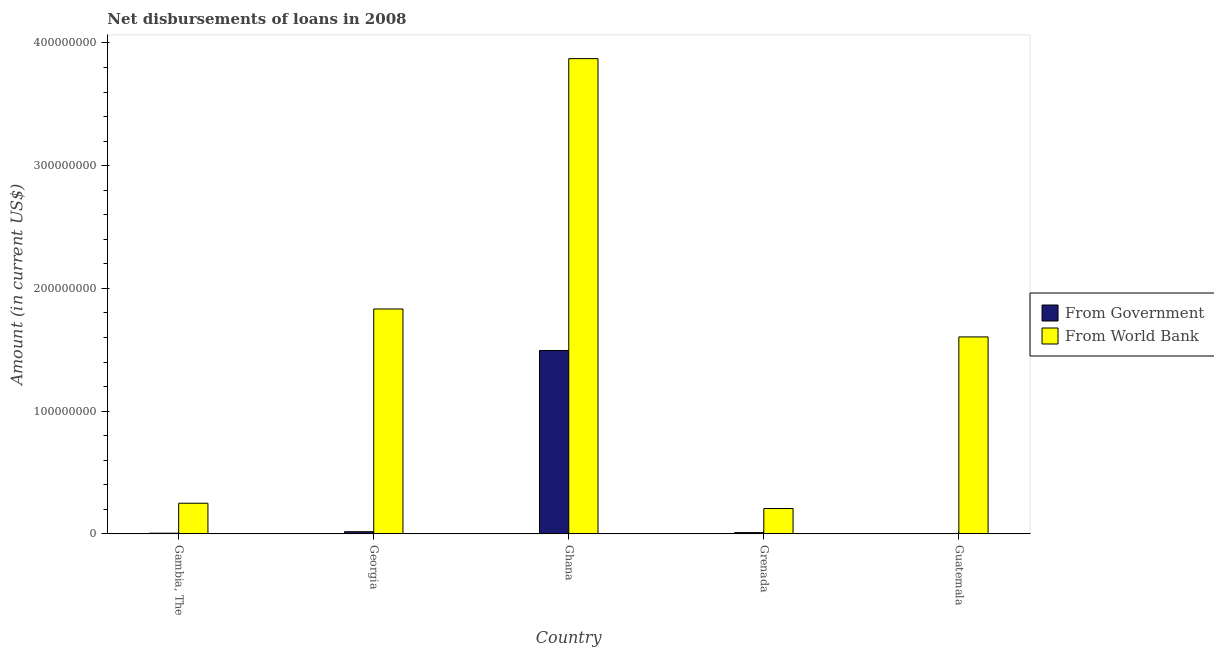How many bars are there on the 5th tick from the right?
Your answer should be compact. 2. What is the label of the 2nd group of bars from the left?
Ensure brevity in your answer.  Georgia. In how many cases, is the number of bars for a given country not equal to the number of legend labels?
Keep it short and to the point. 1. What is the net disbursements of loan from government in Guatemala?
Ensure brevity in your answer.  0. Across all countries, what is the maximum net disbursements of loan from government?
Offer a very short reply. 1.49e+08. Across all countries, what is the minimum net disbursements of loan from world bank?
Keep it short and to the point. 2.07e+07. What is the total net disbursements of loan from government in the graph?
Provide a succinct answer. 1.53e+08. What is the difference between the net disbursements of loan from government in Georgia and that in Ghana?
Your answer should be very brief. -1.48e+08. What is the difference between the net disbursements of loan from government in Grenada and the net disbursements of loan from world bank in Georgia?
Your answer should be very brief. -1.82e+08. What is the average net disbursements of loan from world bank per country?
Your answer should be very brief. 1.55e+08. What is the difference between the net disbursements of loan from world bank and net disbursements of loan from government in Grenada?
Offer a terse response. 1.96e+07. What is the ratio of the net disbursements of loan from world bank in Georgia to that in Guatemala?
Keep it short and to the point. 1.14. Is the difference between the net disbursements of loan from world bank in Gambia, The and Grenada greater than the difference between the net disbursements of loan from government in Gambia, The and Grenada?
Your answer should be compact. Yes. What is the difference between the highest and the second highest net disbursements of loan from government?
Offer a terse response. 1.48e+08. What is the difference between the highest and the lowest net disbursements of loan from government?
Make the answer very short. 1.49e+08. In how many countries, is the net disbursements of loan from government greater than the average net disbursements of loan from government taken over all countries?
Give a very brief answer. 1. Is the sum of the net disbursements of loan from world bank in Gambia, The and Guatemala greater than the maximum net disbursements of loan from government across all countries?
Give a very brief answer. Yes. How many bars are there?
Offer a terse response. 9. How many countries are there in the graph?
Make the answer very short. 5. What is the difference between two consecutive major ticks on the Y-axis?
Your answer should be compact. 1.00e+08. Does the graph contain grids?
Give a very brief answer. No. How many legend labels are there?
Your answer should be very brief. 2. How are the legend labels stacked?
Make the answer very short. Vertical. What is the title of the graph?
Offer a very short reply. Net disbursements of loans in 2008. Does "IMF concessional" appear as one of the legend labels in the graph?
Offer a very short reply. No. What is the label or title of the Y-axis?
Provide a short and direct response. Amount (in current US$). What is the Amount (in current US$) of From Government in Gambia, The?
Your response must be concise. 5.37e+05. What is the Amount (in current US$) in From World Bank in Gambia, The?
Ensure brevity in your answer.  2.50e+07. What is the Amount (in current US$) of From Government in Georgia?
Make the answer very short. 1.75e+06. What is the Amount (in current US$) of From World Bank in Georgia?
Ensure brevity in your answer.  1.83e+08. What is the Amount (in current US$) in From Government in Ghana?
Give a very brief answer. 1.49e+08. What is the Amount (in current US$) in From World Bank in Ghana?
Offer a very short reply. 3.87e+08. What is the Amount (in current US$) in From Government in Grenada?
Your response must be concise. 1.02e+06. What is the Amount (in current US$) in From World Bank in Grenada?
Make the answer very short. 2.07e+07. What is the Amount (in current US$) in From World Bank in Guatemala?
Provide a succinct answer. 1.60e+08. Across all countries, what is the maximum Amount (in current US$) of From Government?
Keep it short and to the point. 1.49e+08. Across all countries, what is the maximum Amount (in current US$) in From World Bank?
Give a very brief answer. 3.87e+08. Across all countries, what is the minimum Amount (in current US$) in From World Bank?
Offer a very short reply. 2.07e+07. What is the total Amount (in current US$) of From Government in the graph?
Provide a short and direct response. 1.53e+08. What is the total Amount (in current US$) of From World Bank in the graph?
Offer a terse response. 7.77e+08. What is the difference between the Amount (in current US$) of From Government in Gambia, The and that in Georgia?
Offer a very short reply. -1.22e+06. What is the difference between the Amount (in current US$) in From World Bank in Gambia, The and that in Georgia?
Make the answer very short. -1.58e+08. What is the difference between the Amount (in current US$) in From Government in Gambia, The and that in Ghana?
Provide a succinct answer. -1.49e+08. What is the difference between the Amount (in current US$) in From World Bank in Gambia, The and that in Ghana?
Your answer should be compact. -3.62e+08. What is the difference between the Amount (in current US$) of From Government in Gambia, The and that in Grenada?
Make the answer very short. -4.86e+05. What is the difference between the Amount (in current US$) in From World Bank in Gambia, The and that in Grenada?
Offer a terse response. 4.31e+06. What is the difference between the Amount (in current US$) in From World Bank in Gambia, The and that in Guatemala?
Provide a short and direct response. -1.36e+08. What is the difference between the Amount (in current US$) in From Government in Georgia and that in Ghana?
Your answer should be compact. -1.48e+08. What is the difference between the Amount (in current US$) of From World Bank in Georgia and that in Ghana?
Offer a very short reply. -2.04e+08. What is the difference between the Amount (in current US$) in From Government in Georgia and that in Grenada?
Give a very brief answer. 7.29e+05. What is the difference between the Amount (in current US$) in From World Bank in Georgia and that in Grenada?
Give a very brief answer. 1.63e+08. What is the difference between the Amount (in current US$) of From World Bank in Georgia and that in Guatemala?
Make the answer very short. 2.28e+07. What is the difference between the Amount (in current US$) in From Government in Ghana and that in Grenada?
Make the answer very short. 1.48e+08. What is the difference between the Amount (in current US$) in From World Bank in Ghana and that in Grenada?
Your answer should be compact. 3.67e+08. What is the difference between the Amount (in current US$) in From World Bank in Ghana and that in Guatemala?
Your response must be concise. 2.27e+08. What is the difference between the Amount (in current US$) in From World Bank in Grenada and that in Guatemala?
Your answer should be very brief. -1.40e+08. What is the difference between the Amount (in current US$) of From Government in Gambia, The and the Amount (in current US$) of From World Bank in Georgia?
Provide a succinct answer. -1.83e+08. What is the difference between the Amount (in current US$) of From Government in Gambia, The and the Amount (in current US$) of From World Bank in Ghana?
Your answer should be compact. -3.87e+08. What is the difference between the Amount (in current US$) in From Government in Gambia, The and the Amount (in current US$) in From World Bank in Grenada?
Provide a succinct answer. -2.01e+07. What is the difference between the Amount (in current US$) in From Government in Gambia, The and the Amount (in current US$) in From World Bank in Guatemala?
Your answer should be very brief. -1.60e+08. What is the difference between the Amount (in current US$) of From Government in Georgia and the Amount (in current US$) of From World Bank in Ghana?
Provide a short and direct response. -3.85e+08. What is the difference between the Amount (in current US$) of From Government in Georgia and the Amount (in current US$) of From World Bank in Grenada?
Make the answer very short. -1.89e+07. What is the difference between the Amount (in current US$) of From Government in Georgia and the Amount (in current US$) of From World Bank in Guatemala?
Provide a succinct answer. -1.59e+08. What is the difference between the Amount (in current US$) of From Government in Ghana and the Amount (in current US$) of From World Bank in Grenada?
Give a very brief answer. 1.29e+08. What is the difference between the Amount (in current US$) in From Government in Ghana and the Amount (in current US$) in From World Bank in Guatemala?
Offer a terse response. -1.11e+07. What is the difference between the Amount (in current US$) of From Government in Grenada and the Amount (in current US$) of From World Bank in Guatemala?
Make the answer very short. -1.59e+08. What is the average Amount (in current US$) in From Government per country?
Make the answer very short. 3.05e+07. What is the average Amount (in current US$) in From World Bank per country?
Provide a short and direct response. 1.55e+08. What is the difference between the Amount (in current US$) in From Government and Amount (in current US$) in From World Bank in Gambia, The?
Your answer should be very brief. -2.44e+07. What is the difference between the Amount (in current US$) of From Government and Amount (in current US$) of From World Bank in Georgia?
Keep it short and to the point. -1.81e+08. What is the difference between the Amount (in current US$) in From Government and Amount (in current US$) in From World Bank in Ghana?
Provide a short and direct response. -2.38e+08. What is the difference between the Amount (in current US$) of From Government and Amount (in current US$) of From World Bank in Grenada?
Provide a succinct answer. -1.96e+07. What is the ratio of the Amount (in current US$) in From Government in Gambia, The to that in Georgia?
Offer a very short reply. 0.31. What is the ratio of the Amount (in current US$) in From World Bank in Gambia, The to that in Georgia?
Provide a succinct answer. 0.14. What is the ratio of the Amount (in current US$) of From Government in Gambia, The to that in Ghana?
Offer a very short reply. 0. What is the ratio of the Amount (in current US$) in From World Bank in Gambia, The to that in Ghana?
Ensure brevity in your answer.  0.06. What is the ratio of the Amount (in current US$) in From Government in Gambia, The to that in Grenada?
Keep it short and to the point. 0.52. What is the ratio of the Amount (in current US$) of From World Bank in Gambia, The to that in Grenada?
Give a very brief answer. 1.21. What is the ratio of the Amount (in current US$) of From World Bank in Gambia, The to that in Guatemala?
Give a very brief answer. 0.16. What is the ratio of the Amount (in current US$) of From Government in Georgia to that in Ghana?
Your response must be concise. 0.01. What is the ratio of the Amount (in current US$) in From World Bank in Georgia to that in Ghana?
Keep it short and to the point. 0.47. What is the ratio of the Amount (in current US$) in From Government in Georgia to that in Grenada?
Offer a very short reply. 1.71. What is the ratio of the Amount (in current US$) of From World Bank in Georgia to that in Grenada?
Your answer should be compact. 8.87. What is the ratio of the Amount (in current US$) of From World Bank in Georgia to that in Guatemala?
Keep it short and to the point. 1.14. What is the ratio of the Amount (in current US$) in From Government in Ghana to that in Grenada?
Offer a terse response. 146.04. What is the ratio of the Amount (in current US$) in From World Bank in Ghana to that in Grenada?
Offer a terse response. 18.75. What is the ratio of the Amount (in current US$) of From World Bank in Ghana to that in Guatemala?
Ensure brevity in your answer.  2.41. What is the ratio of the Amount (in current US$) of From World Bank in Grenada to that in Guatemala?
Your answer should be very brief. 0.13. What is the difference between the highest and the second highest Amount (in current US$) in From Government?
Your answer should be very brief. 1.48e+08. What is the difference between the highest and the second highest Amount (in current US$) of From World Bank?
Offer a very short reply. 2.04e+08. What is the difference between the highest and the lowest Amount (in current US$) of From Government?
Your answer should be very brief. 1.49e+08. What is the difference between the highest and the lowest Amount (in current US$) of From World Bank?
Keep it short and to the point. 3.67e+08. 